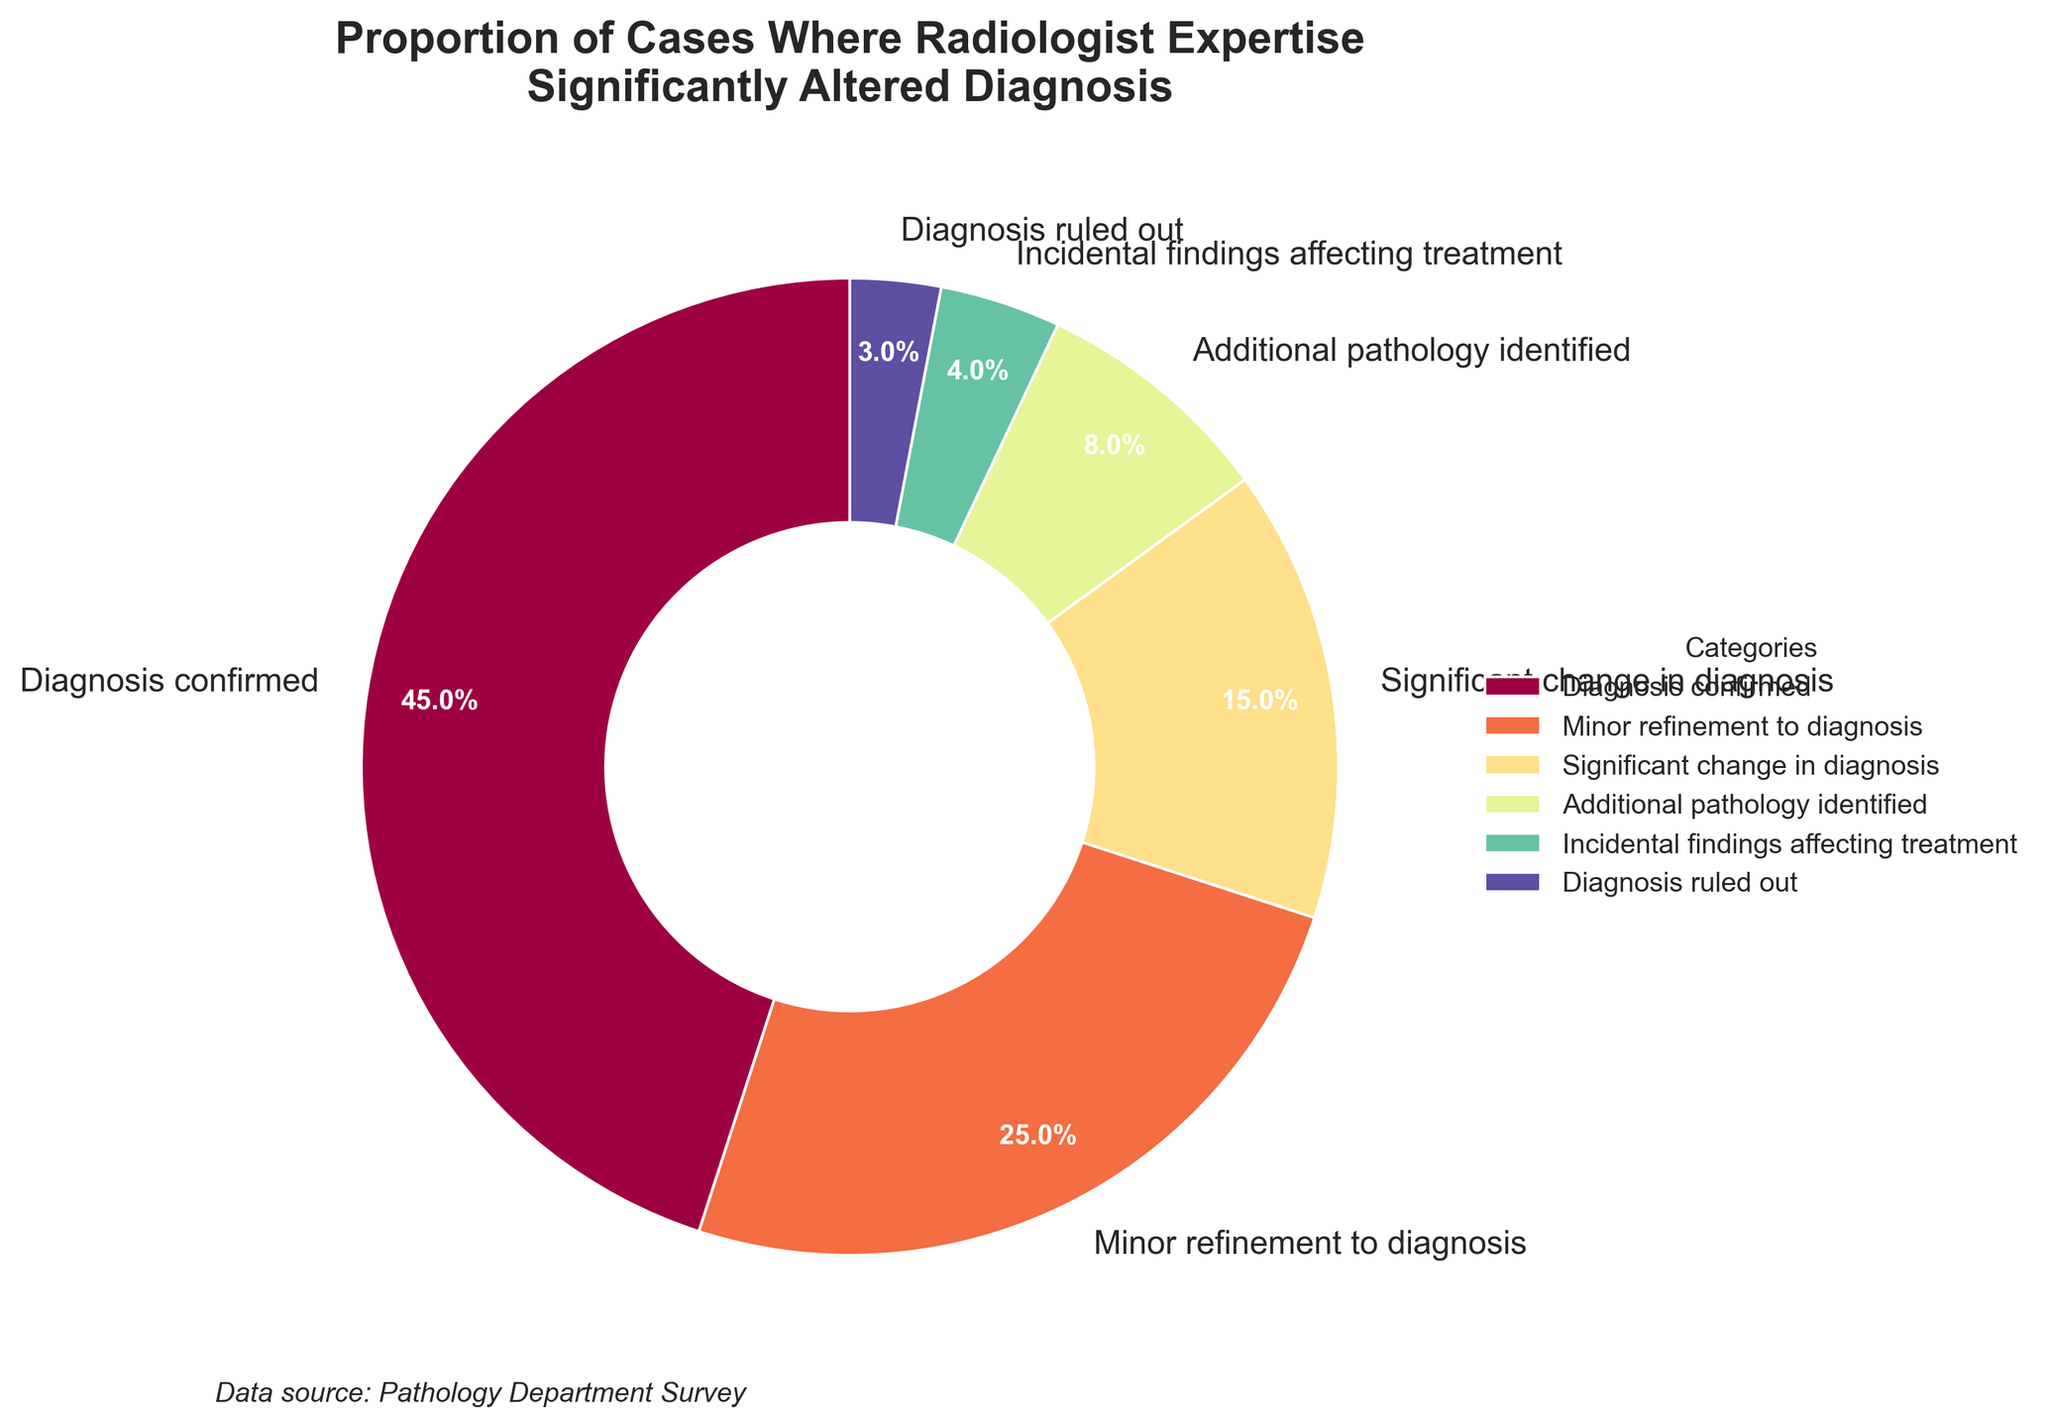What percentage of cases did the radiologist's expertise lead to the diagnosis being confirmed? The pie chart shows the categories along with their respective percentages. The "Diagnosis confirmed" segment has a label showing 45%. Therefore, the percentage of cases where the diagnosis was confirmed is 45%
Answer: 45% Which two categories have the smallest proportions of cases where radiologist expertise altered the diagnosis? By examining the percentages associated with each category on the pie chart, "Diagnosis ruled out" has 3% and "Incidental findings affecting treatment" has 4%, which are the smallest values.
Answer: Diagnosis ruled out, Incidental findings affecting treatment What is the combined percentage of cases where there was either a minor refinement to diagnosis or significant change in diagnosis due to radiologist expertise? The "Minor refinement to diagnosis" and "Significant change in diagnosis" categories are 25% and 15%, respectively. Adding these values gives 25% + 15% = 40%.
Answer: 40% Which segment has a color closest to red, and what does it represent? The pie chart uses color gradients. By observation, the segment with a color closest to red represents "Diagnosis confirmed" which occupies the largest segment labeled 45%.
Answer: Diagnosis confirmed How does the combined percentage of "Additional pathology identified" and "Incidental findings affecting treatment" compare to "Diagnosis confirmed"? "Additional pathology identified" is 8%, and "Incidental findings affecting treatment" is 4%. Their combined percentage is 8% + 4% = 12%. Comparing this to "Diagnosis confirmed" which is 45%, 12% is significantly less than 45%.
Answer: Less than Diagnosis confirmed What proportion of cases did radiologist expertise identify additional pathology? By looking at the pie chart, "Additional pathology identified" is labeled with 8%. Thus, 8% of cases identified additional pathology.
Answer: 8% How significant is the contribution of radiologist expertise to ruling out diagnoses compared to making minor refinements to diagnoses? The category "Diagnosis ruled out" is 3% and "Minor refinement to diagnosis" is 25%. 3% is much smaller compared to 25%.
Answer: Much smaller What is the total percentage of cases where radiologist expertise either ruled out a diagnosis or resulted in incidental findings affecting treatment? "Diagnosis ruled out" is 3% and "Incidental findings affecting treatment" is 4%. Adding these values gives 3% + 4% = 7%.
Answer: 7% In terms of the visual representation of the pie chart, which graphical element corresponds to the largest category and what is its relative size? The largest segment in the pie chart corresponds to "Diagnosis confirmed". This is visually represented as the largest wedge occupying 45% of the pie chart.
Answer: 45% What is the difference in percentage points between the category with the largest proportion and the category with the smallest proportion of cases? "Diagnosis confirmed" has the largest proportion at 45%, and "Diagnosis ruled out" has the smallest proportion at 3%. The difference is 45 - 3 = 42 percentage points.
Answer: 42 percentage points 